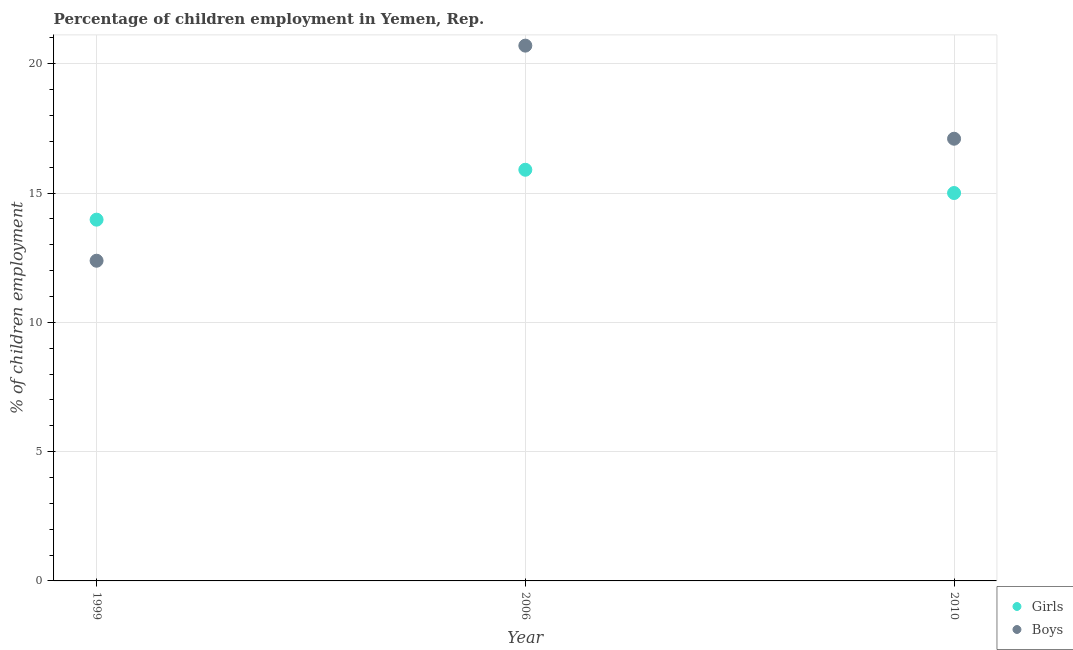How many different coloured dotlines are there?
Offer a terse response. 2. Is the number of dotlines equal to the number of legend labels?
Give a very brief answer. Yes. What is the percentage of employed boys in 1999?
Make the answer very short. 12.38. Across all years, what is the minimum percentage of employed girls?
Provide a short and direct response. 13.97. In which year was the percentage of employed girls maximum?
Offer a very short reply. 2006. What is the total percentage of employed girls in the graph?
Offer a terse response. 44.87. What is the difference between the percentage of employed girls in 2006 and that in 2010?
Provide a short and direct response. 0.9. What is the difference between the percentage of employed boys in 2006 and the percentage of employed girls in 1999?
Provide a short and direct response. 6.73. What is the average percentage of employed boys per year?
Your answer should be compact. 16.73. In the year 2010, what is the difference between the percentage of employed girls and percentage of employed boys?
Your response must be concise. -2.1. In how many years, is the percentage of employed girls greater than 9 %?
Your response must be concise. 3. What is the ratio of the percentage of employed girls in 1999 to that in 2006?
Provide a succinct answer. 0.88. Is the percentage of employed boys in 1999 less than that in 2006?
Your response must be concise. Yes. Is the difference between the percentage of employed girls in 1999 and 2010 greater than the difference between the percentage of employed boys in 1999 and 2010?
Give a very brief answer. Yes. What is the difference between the highest and the second highest percentage of employed boys?
Ensure brevity in your answer.  3.6. What is the difference between the highest and the lowest percentage of employed girls?
Offer a very short reply. 1.93. In how many years, is the percentage of employed girls greater than the average percentage of employed girls taken over all years?
Ensure brevity in your answer.  2. How many years are there in the graph?
Your answer should be compact. 3. Does the graph contain any zero values?
Provide a short and direct response. No. Where does the legend appear in the graph?
Provide a short and direct response. Bottom right. How are the legend labels stacked?
Ensure brevity in your answer.  Vertical. What is the title of the graph?
Offer a very short reply. Percentage of children employment in Yemen, Rep. What is the label or title of the Y-axis?
Your answer should be compact. % of children employment. What is the % of children employment of Girls in 1999?
Your answer should be very brief. 13.97. What is the % of children employment of Boys in 1999?
Offer a terse response. 12.38. What is the % of children employment of Boys in 2006?
Provide a succinct answer. 20.7. What is the % of children employment in Girls in 2010?
Provide a succinct answer. 15. Across all years, what is the maximum % of children employment of Girls?
Keep it short and to the point. 15.9. Across all years, what is the maximum % of children employment in Boys?
Offer a very short reply. 20.7. Across all years, what is the minimum % of children employment in Girls?
Provide a succinct answer. 13.97. Across all years, what is the minimum % of children employment of Boys?
Offer a terse response. 12.38. What is the total % of children employment in Girls in the graph?
Provide a short and direct response. 44.87. What is the total % of children employment of Boys in the graph?
Your answer should be compact. 50.18. What is the difference between the % of children employment in Girls in 1999 and that in 2006?
Your response must be concise. -1.93. What is the difference between the % of children employment in Boys in 1999 and that in 2006?
Your response must be concise. -8.32. What is the difference between the % of children employment of Girls in 1999 and that in 2010?
Your answer should be very brief. -1.03. What is the difference between the % of children employment of Boys in 1999 and that in 2010?
Your answer should be compact. -4.72. What is the difference between the % of children employment in Boys in 2006 and that in 2010?
Your answer should be compact. 3.6. What is the difference between the % of children employment in Girls in 1999 and the % of children employment in Boys in 2006?
Keep it short and to the point. -6.73. What is the difference between the % of children employment of Girls in 1999 and the % of children employment of Boys in 2010?
Provide a short and direct response. -3.13. What is the difference between the % of children employment of Girls in 2006 and the % of children employment of Boys in 2010?
Your answer should be compact. -1.2. What is the average % of children employment of Girls per year?
Your response must be concise. 14.96. What is the average % of children employment in Boys per year?
Give a very brief answer. 16.73. In the year 1999, what is the difference between the % of children employment of Girls and % of children employment of Boys?
Your answer should be compact. 1.59. What is the ratio of the % of children employment of Girls in 1999 to that in 2006?
Keep it short and to the point. 0.88. What is the ratio of the % of children employment of Boys in 1999 to that in 2006?
Provide a short and direct response. 0.6. What is the ratio of the % of children employment in Girls in 1999 to that in 2010?
Provide a succinct answer. 0.93. What is the ratio of the % of children employment in Boys in 1999 to that in 2010?
Provide a short and direct response. 0.72. What is the ratio of the % of children employment in Girls in 2006 to that in 2010?
Give a very brief answer. 1.06. What is the ratio of the % of children employment in Boys in 2006 to that in 2010?
Make the answer very short. 1.21. What is the difference between the highest and the lowest % of children employment in Girls?
Your answer should be very brief. 1.93. What is the difference between the highest and the lowest % of children employment of Boys?
Offer a terse response. 8.32. 